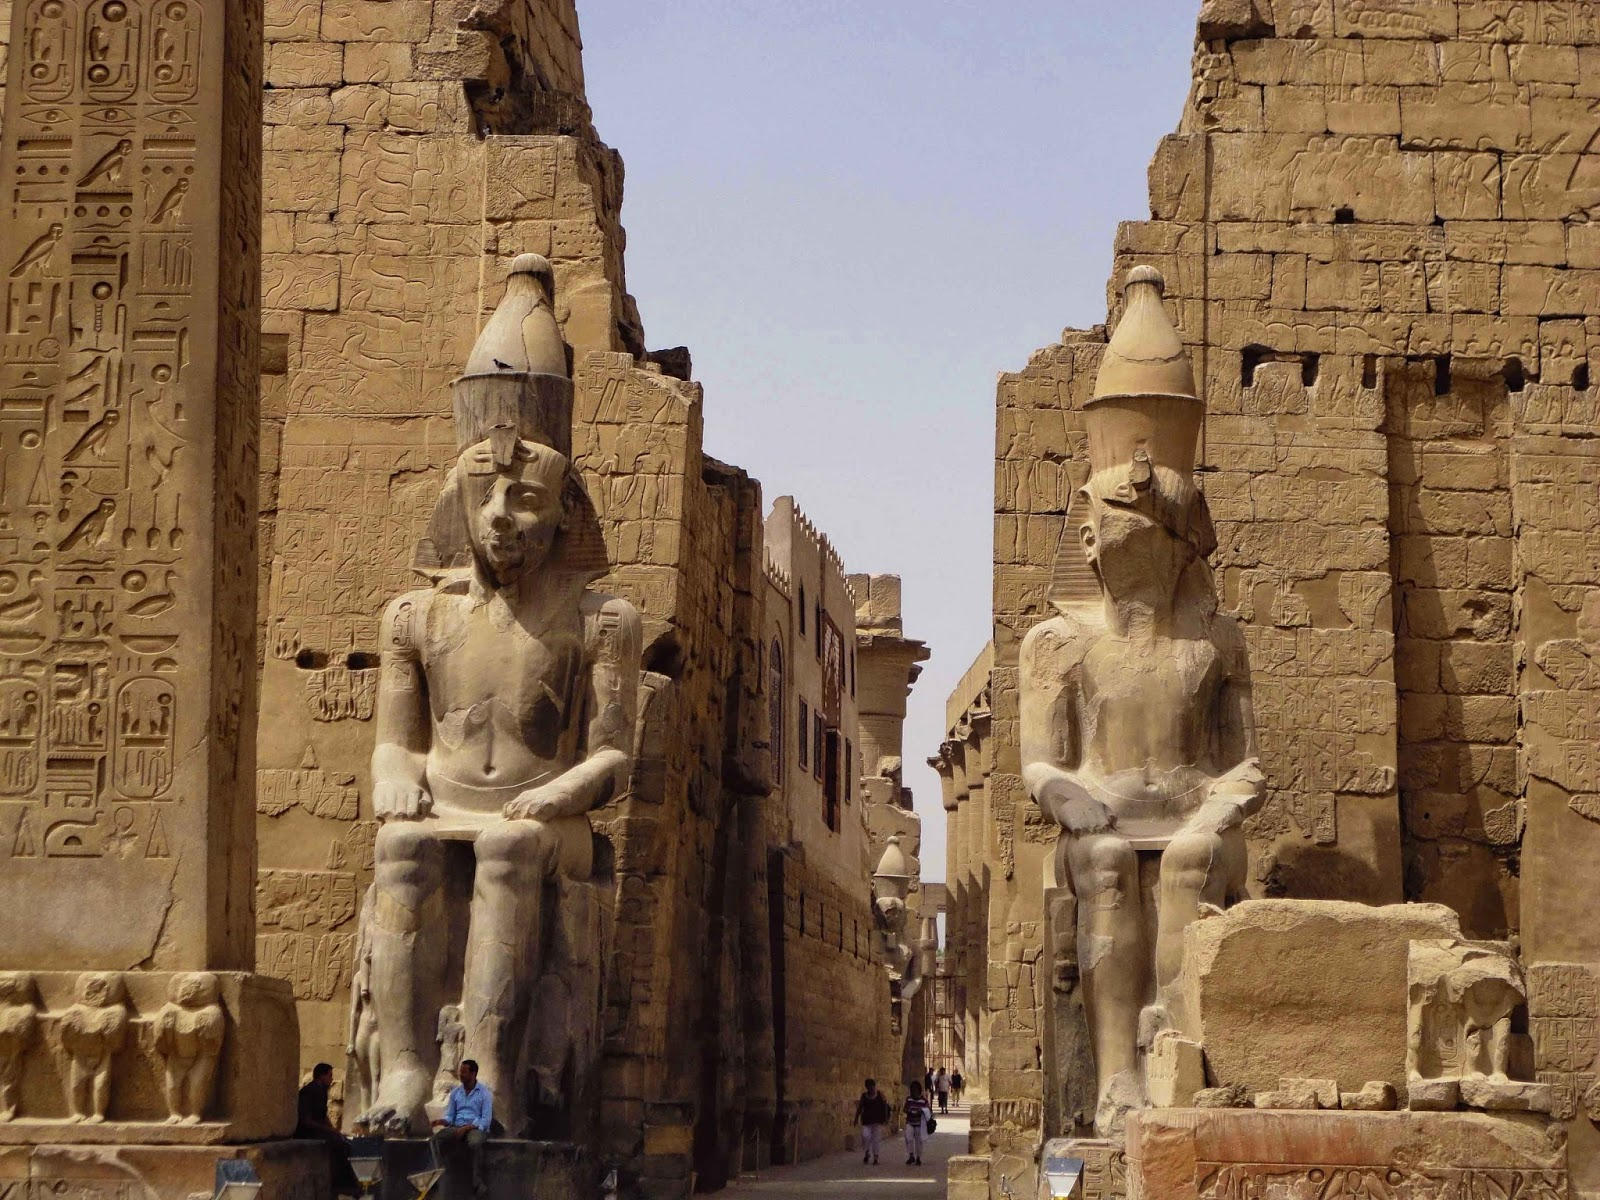If these statues could speak, what stories might they tell? If the statues at Luxor Temple could speak, they would recount tales of glory and reverence, of kings and gods. They might describe the grand ceremonies they witnessed, the coronations, and the offerings made by countless generations. They would speak of the hands that carved them, the artisans whose skill was passed down through the ages.

The statues would share stories of the faithful pilgrims who traveled great distances to pay homage, the changing seasons they have endured, and the historical events that unfolded around them. They would whisper of the secrets etched into the temple walls, the prayers they have silently heard, and the enduring spirit of a civilization determined to immortalize its legacy. How do the weathered faces of these statues reflect the passage of time? The weathered faces of these statues are a testament to resilience and endurance. Each crack and chipped surface narrates the relentless passage of time. Standing exposed to the elements for millennia, they have borne the brunt of fierce deserts, scorching suns, and occasional rains. Despite the erosion, the statues' majestic presence remains unshaken, symbolizing strength and fortitude.

Their weathered appearance also signifies transformation, illustrating how time can alter forms while preserving essence. The softened features evoke a sense of history, humbling viewers with the realization of the age and events these silent sentinels have witnessed. They are enduring symbols of a civilization that has long gone but still speaks volumes through its enduring art and architecture. 